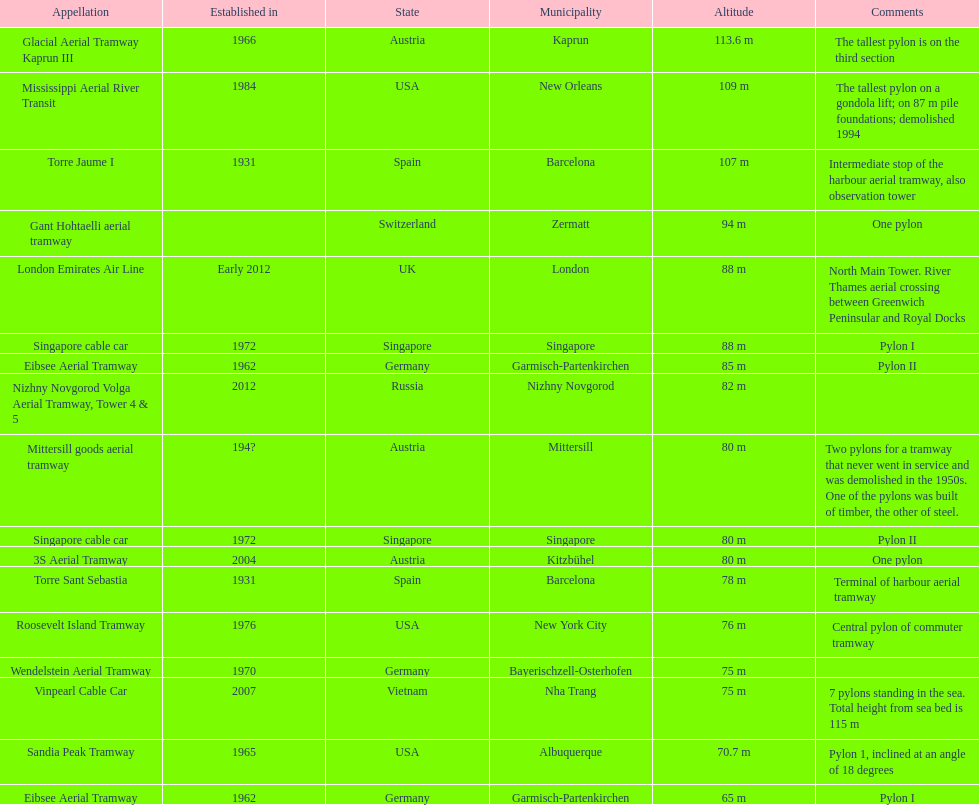How many pylons are at least 80 meters tall? 11. 